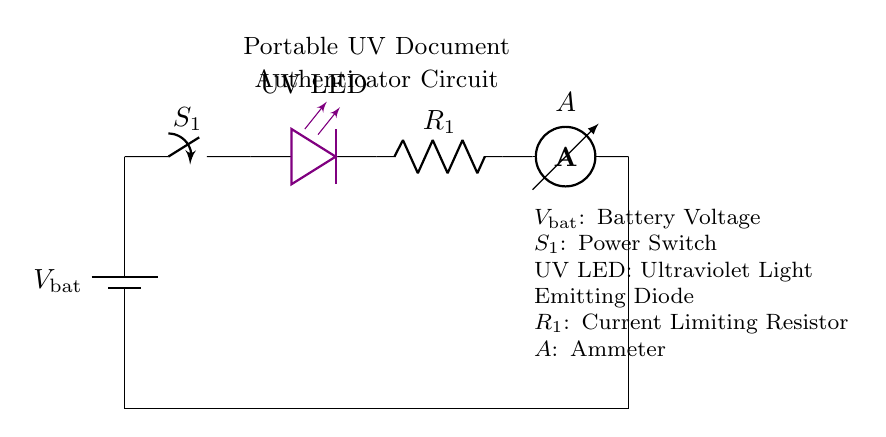What type of circuit is depicted? The circuit is a series circuit, as all components are connected end-to-end, and current flows through each component in a single path.
Answer: Series circuit What component is labeled as \( S_1 \)? \( S_1 \) is the power switch in the circuit, used to control the flow of electricity through the circuit.
Answer: Power switch How many components are in the circuit? There are five components in total: a battery, a switch, a UV LED, a resistor, and an ammeter.
Answer: Five What is the purpose of the resistor \( R_1 \)? The resistor \( R_1 \) limits the current flowing through the UV LED to prevent it from getting damaged, ensuring it operates safely within its rated specifications.
Answer: Current limiting What is the measurement indicated by the ammeter? The ammeter measures the current flowing through the circuit, providing a numerical value in amperes that reflects the amount of electric charge passing through a specific point per second.
Answer: Current If the battery voltage is \( 9V \), what can be inferred about the current flowing through the circuit? Given \( 9V \) as the battery voltage, the amount of current flowing can be determined using Ohm’s Law, considering the resistance value; without further information about \( R_1 \), an exact current cannot be calculated, but it will be influenced directly by both \( V \) and \( R_1 \).
Answer: Voltage and resistance dependent What is the color of the LED in the circuit? The UV LED is specified as being colored violet, indicating its capacity to emit ultraviolet light.
Answer: Violet 